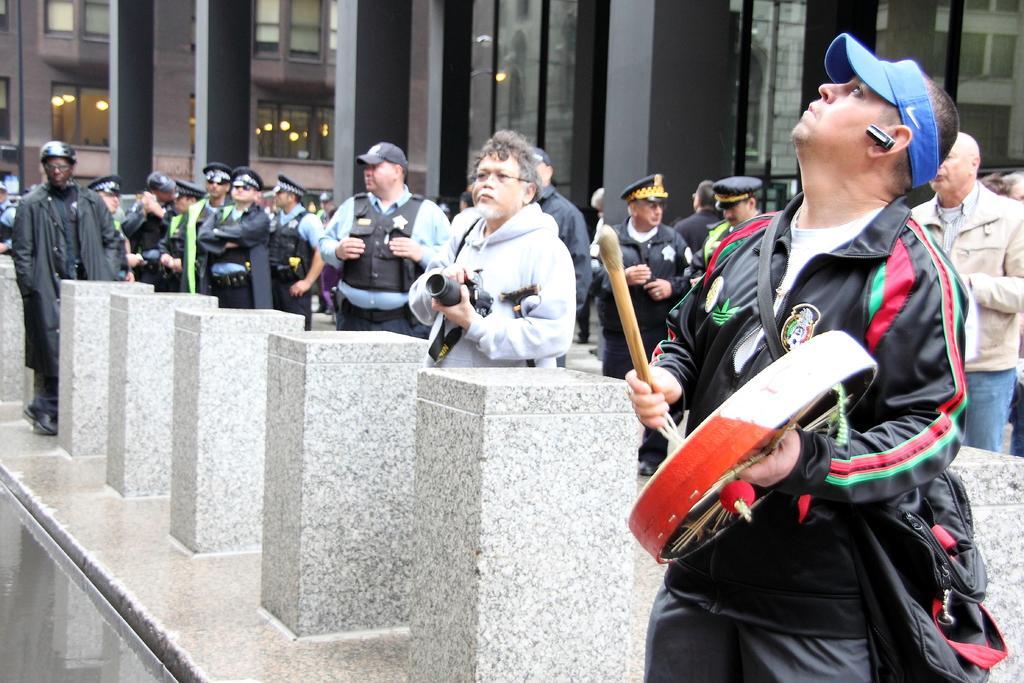In one or two sentences, can you explain what this image depicts? In this image, we can see persons wearing clothes. There are cement poles at the bottom of the image. There are pillars at the top of the image. There is a person on the right side of the image holding objects with his hands. There is an another person in the middle of the image holding a camera with his hands. 